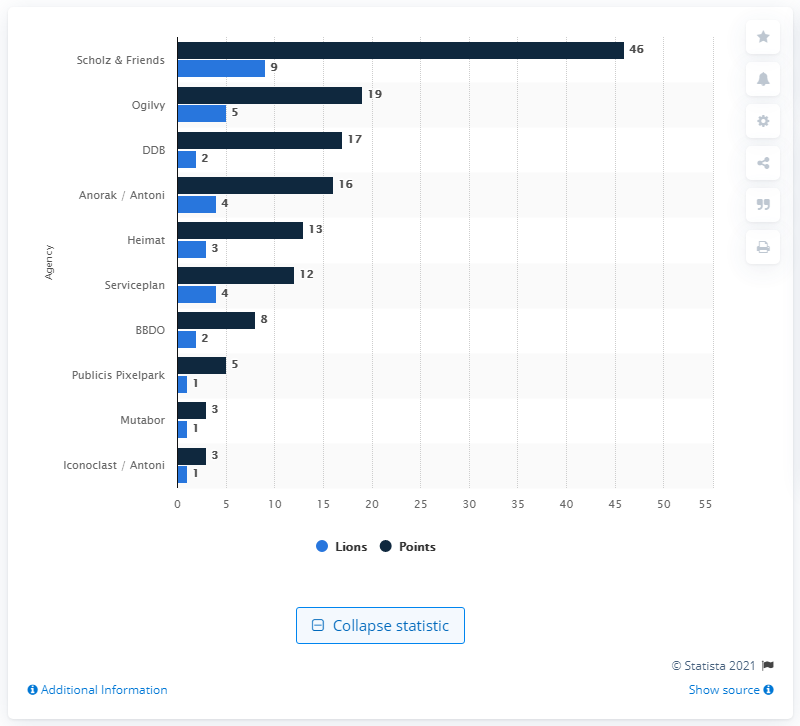Indicate a few pertinent items in this graphic. Scholz & Friends was the leading German advertising agency at the 2019 Cannes Lions Festival. Scholz & Friends received 46 points. 